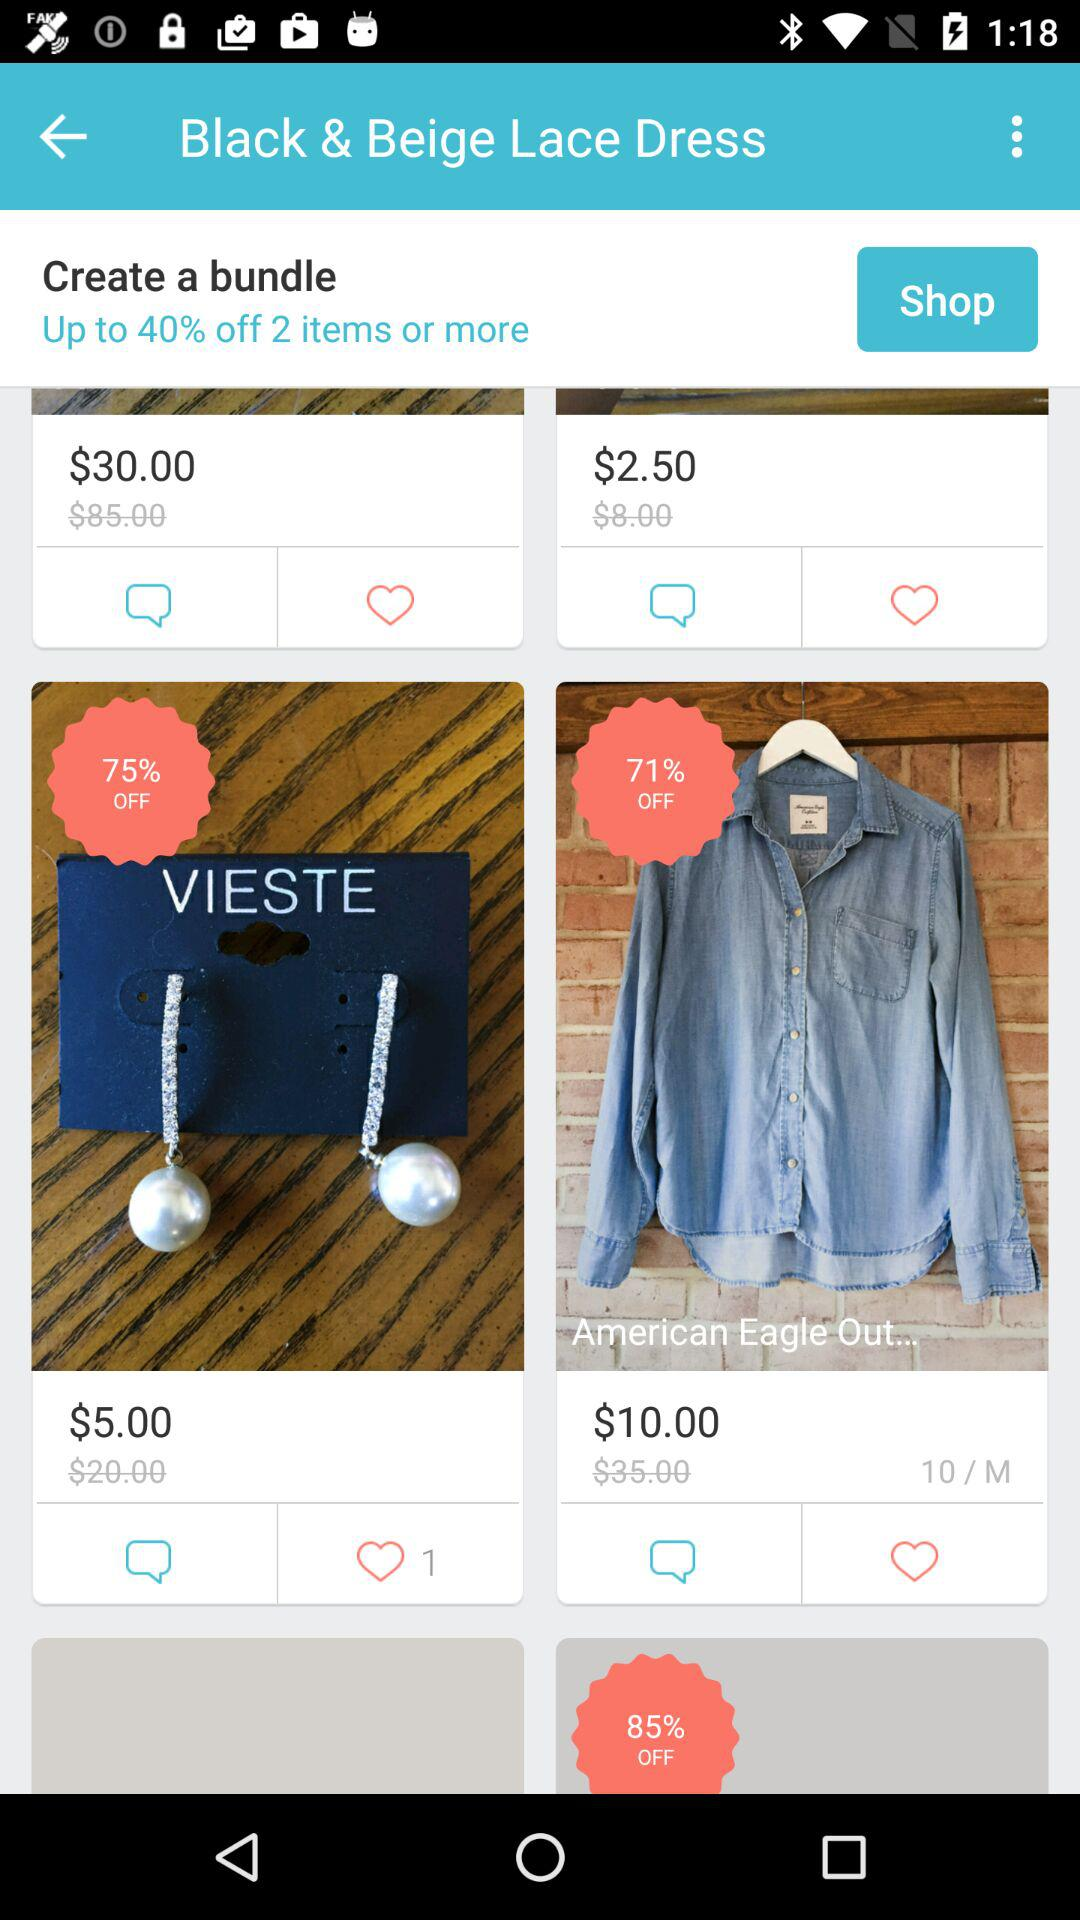How much of a percentage discount can we get for two items? You can get a discount of up to 40%. 